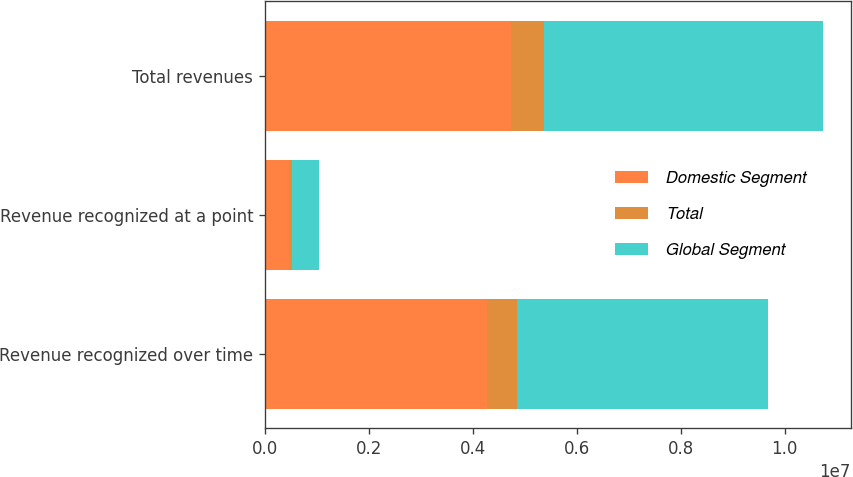<chart> <loc_0><loc_0><loc_500><loc_500><stacked_bar_chart><ecel><fcel>Revenue recognized over time<fcel>Revenue recognized at a point<fcel>Total revenues<nl><fcel>Domestic Segment<fcel>4.27193e+06<fcel>458332<fcel>4.73027e+06<nl><fcel>Total<fcel>569780<fcel>66279<fcel>636059<nl><fcel>Global Segment<fcel>4.84171e+06<fcel>524611<fcel>5.36632e+06<nl></chart> 